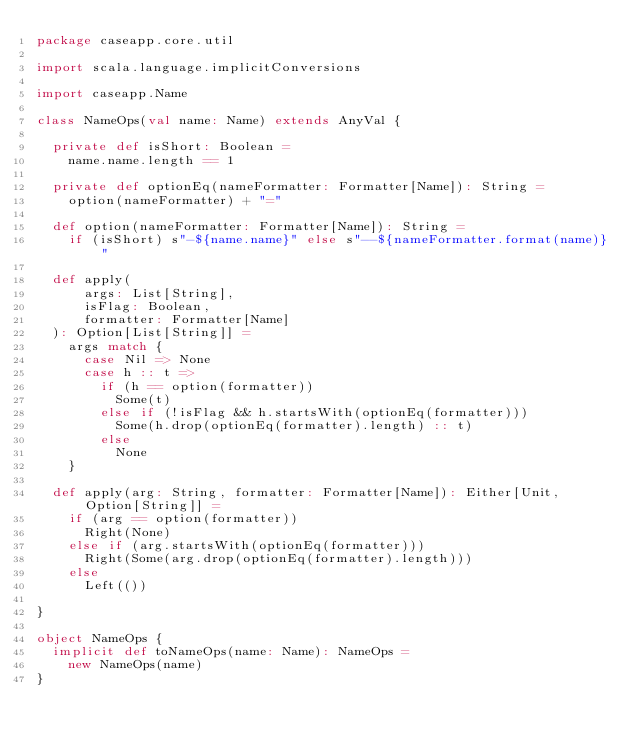Convert code to text. <code><loc_0><loc_0><loc_500><loc_500><_Scala_>package caseapp.core.util

import scala.language.implicitConversions

import caseapp.Name

class NameOps(val name: Name) extends AnyVal {

  private def isShort: Boolean =
    name.name.length == 1

  private def optionEq(nameFormatter: Formatter[Name]): String = 
    option(nameFormatter) + "="

  def option(nameFormatter: Formatter[Name]): String =
    if (isShort) s"-${name.name}" else s"--${nameFormatter.format(name)}"

  def apply(
      args: List[String],
      isFlag: Boolean,
      formatter: Formatter[Name]
  ): Option[List[String]] =
    args match {
      case Nil => None
      case h :: t =>
        if (h == option(formatter))
          Some(t)
        else if (!isFlag && h.startsWith(optionEq(formatter)))
          Some(h.drop(optionEq(formatter).length) :: t)
        else
          None
    }

  def apply(arg: String, formatter: Formatter[Name]): Either[Unit, Option[String]] =
    if (arg == option(formatter))
      Right(None)
    else if (arg.startsWith(optionEq(formatter)))
      Right(Some(arg.drop(optionEq(formatter).length)))
    else
      Left(())

}

object NameOps {
  implicit def toNameOps(name: Name): NameOps =
    new NameOps(name)
}
</code> 